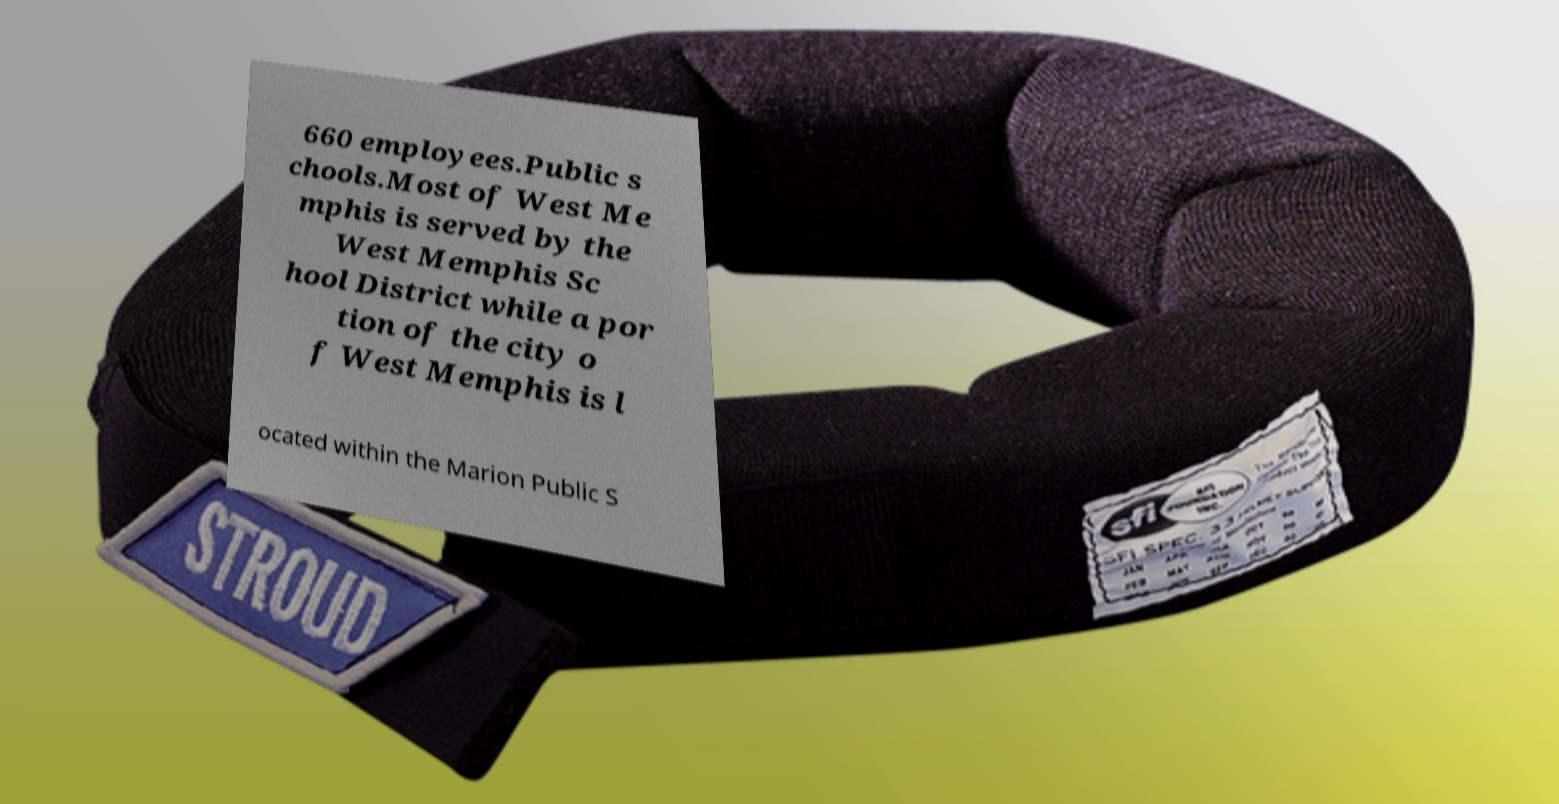There's text embedded in this image that I need extracted. Can you transcribe it verbatim? 660 employees.Public s chools.Most of West Me mphis is served by the West Memphis Sc hool District while a por tion of the city o f West Memphis is l ocated within the Marion Public S 